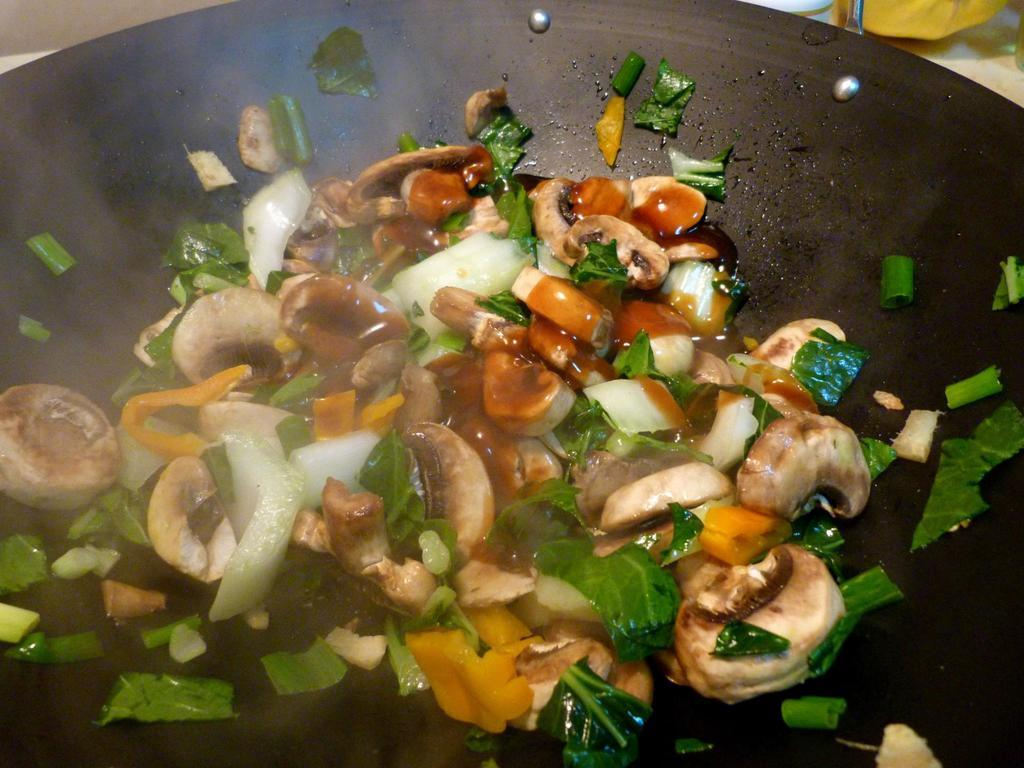What is the main object in the center of the image? There is a wok in the center of the image. What is inside the wok? There are vegetables in the wok. What type of cakes are being cut with scissors in the image? There are no cakes or scissors present in the image; it features a wok with vegetables. 